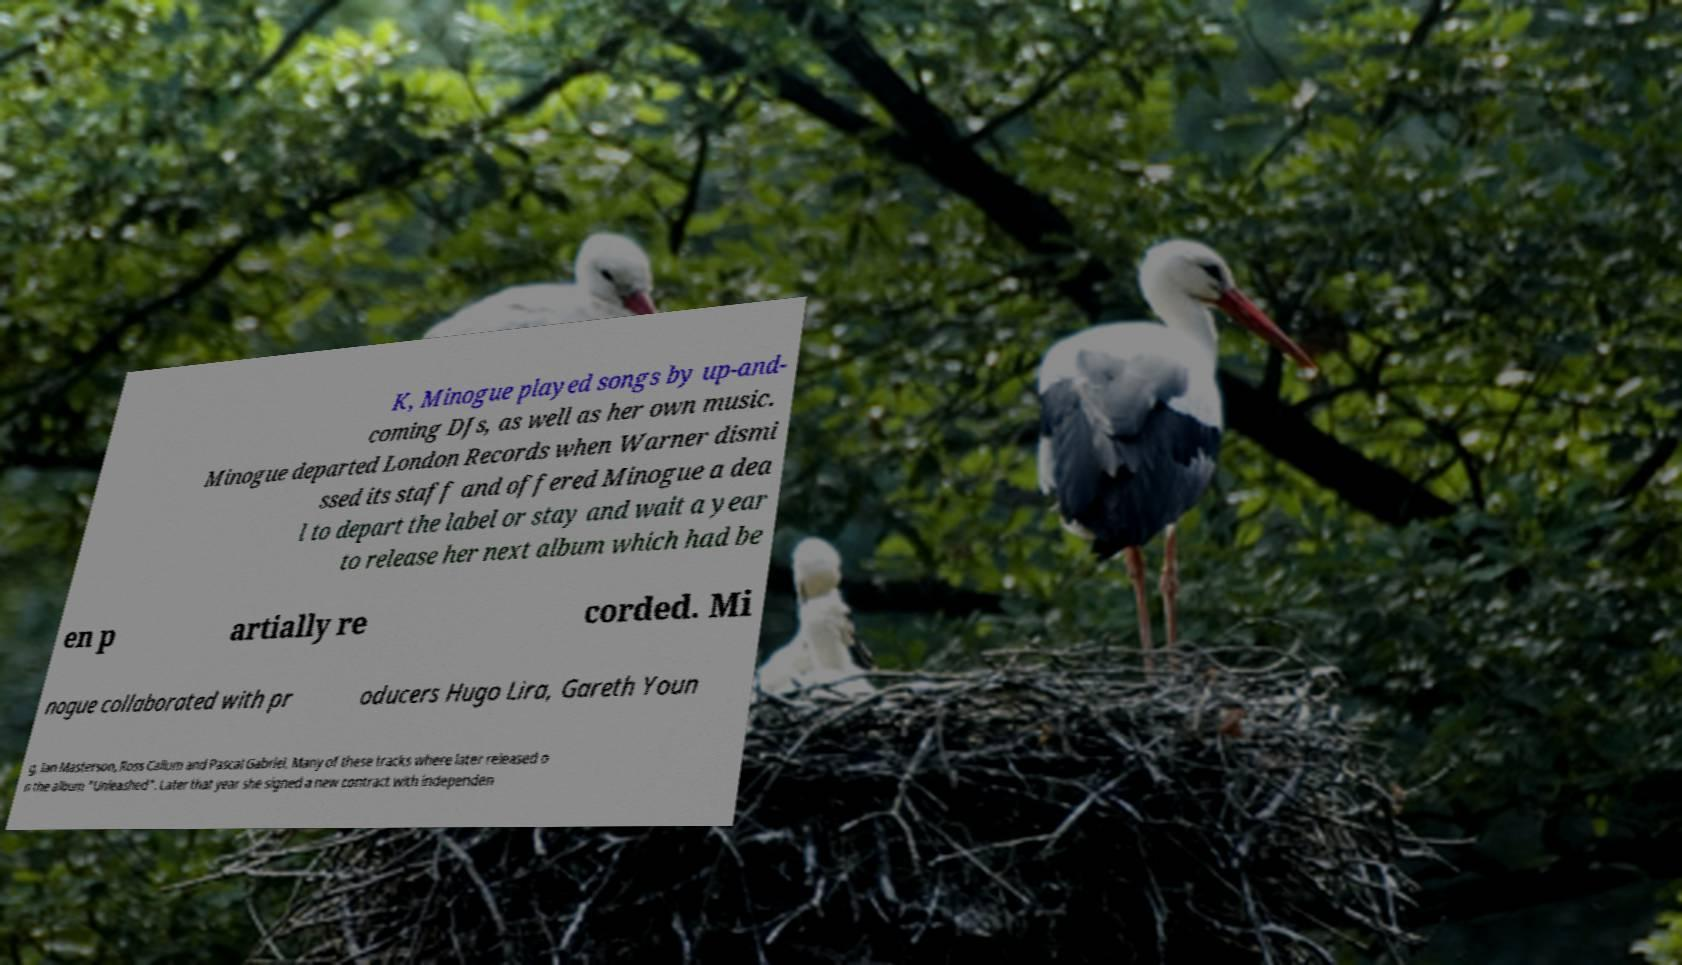For documentation purposes, I need the text within this image transcribed. Could you provide that? K, Minogue played songs by up-and- coming DJs, as well as her own music. Minogue departed London Records when Warner dismi ssed its staff and offered Minogue a dea l to depart the label or stay and wait a year to release her next album which had be en p artially re corded. Mi nogue collaborated with pr oducers Hugo Lira, Gareth Youn g, Ian Masterson, Ross Callum and Pascal Gabriel. Many of these tracks where later released o n the album "Unleashed". Later that year she signed a new contract with independen 